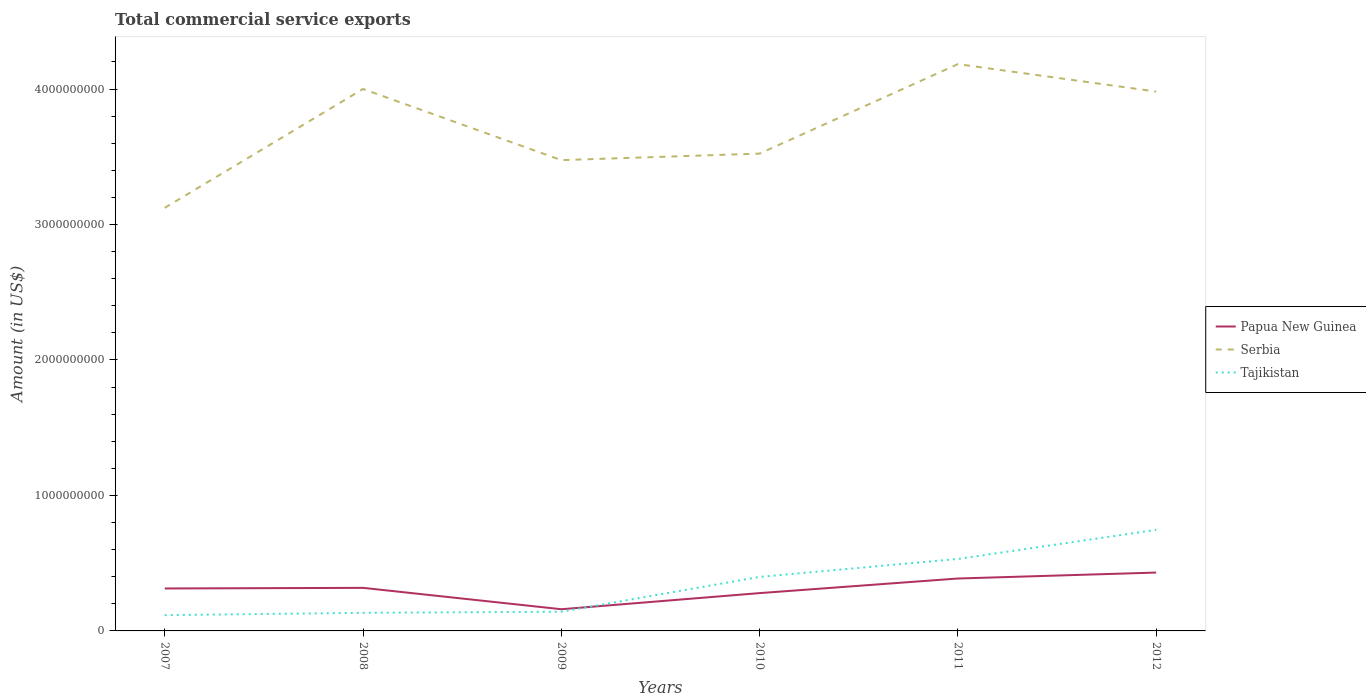How many different coloured lines are there?
Give a very brief answer. 3. Across all years, what is the maximum total commercial service exports in Tajikistan?
Ensure brevity in your answer.  1.16e+08. In which year was the total commercial service exports in Tajikistan maximum?
Provide a succinct answer. 2007. What is the total total commercial service exports in Tajikistan in the graph?
Ensure brevity in your answer.  -6.30e+08. What is the difference between the highest and the second highest total commercial service exports in Serbia?
Make the answer very short. 1.06e+09. Is the total commercial service exports in Papua New Guinea strictly greater than the total commercial service exports in Tajikistan over the years?
Offer a terse response. No. How many years are there in the graph?
Your response must be concise. 6. What is the difference between two consecutive major ticks on the Y-axis?
Provide a succinct answer. 1.00e+09. Does the graph contain grids?
Offer a very short reply. No. Where does the legend appear in the graph?
Provide a succinct answer. Center right. How many legend labels are there?
Your answer should be compact. 3. How are the legend labels stacked?
Offer a terse response. Vertical. What is the title of the graph?
Provide a short and direct response. Total commercial service exports. Does "Thailand" appear as one of the legend labels in the graph?
Offer a very short reply. No. What is the Amount (in US$) in Papua New Guinea in 2007?
Ensure brevity in your answer.  3.13e+08. What is the Amount (in US$) of Serbia in 2007?
Keep it short and to the point. 3.12e+09. What is the Amount (in US$) in Tajikistan in 2007?
Give a very brief answer. 1.16e+08. What is the Amount (in US$) in Papua New Guinea in 2008?
Provide a succinct answer. 3.18e+08. What is the Amount (in US$) of Serbia in 2008?
Provide a succinct answer. 4.00e+09. What is the Amount (in US$) in Tajikistan in 2008?
Provide a succinct answer. 1.34e+08. What is the Amount (in US$) in Papua New Guinea in 2009?
Give a very brief answer. 1.60e+08. What is the Amount (in US$) of Serbia in 2009?
Ensure brevity in your answer.  3.48e+09. What is the Amount (in US$) in Tajikistan in 2009?
Provide a succinct answer. 1.42e+08. What is the Amount (in US$) of Papua New Guinea in 2010?
Provide a short and direct response. 2.79e+08. What is the Amount (in US$) of Serbia in 2010?
Your answer should be very brief. 3.52e+09. What is the Amount (in US$) of Tajikistan in 2010?
Make the answer very short. 3.99e+08. What is the Amount (in US$) in Papua New Guinea in 2011?
Offer a terse response. 3.87e+08. What is the Amount (in US$) in Serbia in 2011?
Give a very brief answer. 4.18e+09. What is the Amount (in US$) in Tajikistan in 2011?
Provide a short and direct response. 5.31e+08. What is the Amount (in US$) of Papua New Guinea in 2012?
Make the answer very short. 4.31e+08. What is the Amount (in US$) of Serbia in 2012?
Offer a very short reply. 3.98e+09. What is the Amount (in US$) in Tajikistan in 2012?
Your answer should be compact. 7.46e+08. Across all years, what is the maximum Amount (in US$) of Papua New Guinea?
Offer a very short reply. 4.31e+08. Across all years, what is the maximum Amount (in US$) of Serbia?
Ensure brevity in your answer.  4.18e+09. Across all years, what is the maximum Amount (in US$) of Tajikistan?
Your response must be concise. 7.46e+08. Across all years, what is the minimum Amount (in US$) in Papua New Guinea?
Make the answer very short. 1.60e+08. Across all years, what is the minimum Amount (in US$) of Serbia?
Your answer should be compact. 3.12e+09. Across all years, what is the minimum Amount (in US$) of Tajikistan?
Make the answer very short. 1.16e+08. What is the total Amount (in US$) in Papua New Guinea in the graph?
Provide a succinct answer. 1.89e+09. What is the total Amount (in US$) of Serbia in the graph?
Your answer should be compact. 2.23e+1. What is the total Amount (in US$) of Tajikistan in the graph?
Offer a very short reply. 2.07e+09. What is the difference between the Amount (in US$) of Papua New Guinea in 2007 and that in 2008?
Make the answer very short. -4.53e+06. What is the difference between the Amount (in US$) in Serbia in 2007 and that in 2008?
Provide a short and direct response. -8.77e+08. What is the difference between the Amount (in US$) in Tajikistan in 2007 and that in 2008?
Your answer should be compact. -1.71e+07. What is the difference between the Amount (in US$) of Papua New Guinea in 2007 and that in 2009?
Your response must be concise. 1.53e+08. What is the difference between the Amount (in US$) of Serbia in 2007 and that in 2009?
Give a very brief answer. -3.52e+08. What is the difference between the Amount (in US$) in Tajikistan in 2007 and that in 2009?
Provide a succinct answer. -2.53e+07. What is the difference between the Amount (in US$) of Papua New Guinea in 2007 and that in 2010?
Ensure brevity in your answer.  3.43e+07. What is the difference between the Amount (in US$) in Serbia in 2007 and that in 2010?
Provide a succinct answer. -4.00e+08. What is the difference between the Amount (in US$) of Tajikistan in 2007 and that in 2010?
Your answer should be very brief. -2.82e+08. What is the difference between the Amount (in US$) of Papua New Guinea in 2007 and that in 2011?
Keep it short and to the point. -7.35e+07. What is the difference between the Amount (in US$) of Serbia in 2007 and that in 2011?
Your answer should be compact. -1.06e+09. What is the difference between the Amount (in US$) in Tajikistan in 2007 and that in 2011?
Make the answer very short. -4.15e+08. What is the difference between the Amount (in US$) in Papua New Guinea in 2007 and that in 2012?
Offer a terse response. -1.17e+08. What is the difference between the Amount (in US$) in Serbia in 2007 and that in 2012?
Provide a succinct answer. -8.58e+08. What is the difference between the Amount (in US$) of Tajikistan in 2007 and that in 2012?
Offer a terse response. -6.30e+08. What is the difference between the Amount (in US$) of Papua New Guinea in 2008 and that in 2009?
Offer a very short reply. 1.58e+08. What is the difference between the Amount (in US$) of Serbia in 2008 and that in 2009?
Keep it short and to the point. 5.25e+08. What is the difference between the Amount (in US$) of Tajikistan in 2008 and that in 2009?
Your response must be concise. -8.19e+06. What is the difference between the Amount (in US$) in Papua New Guinea in 2008 and that in 2010?
Your answer should be compact. 3.88e+07. What is the difference between the Amount (in US$) of Serbia in 2008 and that in 2010?
Offer a very short reply. 4.77e+08. What is the difference between the Amount (in US$) in Tajikistan in 2008 and that in 2010?
Ensure brevity in your answer.  -2.65e+08. What is the difference between the Amount (in US$) of Papua New Guinea in 2008 and that in 2011?
Make the answer very short. -6.90e+07. What is the difference between the Amount (in US$) of Serbia in 2008 and that in 2011?
Your response must be concise. -1.84e+08. What is the difference between the Amount (in US$) in Tajikistan in 2008 and that in 2011?
Offer a terse response. -3.98e+08. What is the difference between the Amount (in US$) in Papua New Guinea in 2008 and that in 2012?
Keep it short and to the point. -1.13e+08. What is the difference between the Amount (in US$) of Serbia in 2008 and that in 2012?
Ensure brevity in your answer.  1.90e+07. What is the difference between the Amount (in US$) of Tajikistan in 2008 and that in 2012?
Offer a terse response. -6.12e+08. What is the difference between the Amount (in US$) in Papua New Guinea in 2009 and that in 2010?
Your answer should be compact. -1.19e+08. What is the difference between the Amount (in US$) of Serbia in 2009 and that in 2010?
Offer a very short reply. -4.81e+07. What is the difference between the Amount (in US$) of Tajikistan in 2009 and that in 2010?
Provide a succinct answer. -2.57e+08. What is the difference between the Amount (in US$) of Papua New Guinea in 2009 and that in 2011?
Offer a terse response. -2.27e+08. What is the difference between the Amount (in US$) of Serbia in 2009 and that in 2011?
Ensure brevity in your answer.  -7.09e+08. What is the difference between the Amount (in US$) of Tajikistan in 2009 and that in 2011?
Offer a terse response. -3.90e+08. What is the difference between the Amount (in US$) in Papua New Guinea in 2009 and that in 2012?
Offer a very short reply. -2.71e+08. What is the difference between the Amount (in US$) of Serbia in 2009 and that in 2012?
Your response must be concise. -5.06e+08. What is the difference between the Amount (in US$) of Tajikistan in 2009 and that in 2012?
Your answer should be very brief. -6.04e+08. What is the difference between the Amount (in US$) of Papua New Guinea in 2010 and that in 2011?
Provide a short and direct response. -1.08e+08. What is the difference between the Amount (in US$) of Serbia in 2010 and that in 2011?
Offer a very short reply. -6.61e+08. What is the difference between the Amount (in US$) in Tajikistan in 2010 and that in 2011?
Provide a short and direct response. -1.33e+08. What is the difference between the Amount (in US$) of Papua New Guinea in 2010 and that in 2012?
Your answer should be very brief. -1.52e+08. What is the difference between the Amount (in US$) in Serbia in 2010 and that in 2012?
Your response must be concise. -4.58e+08. What is the difference between the Amount (in US$) of Tajikistan in 2010 and that in 2012?
Your answer should be very brief. -3.47e+08. What is the difference between the Amount (in US$) of Papua New Guinea in 2011 and that in 2012?
Provide a succinct answer. -4.38e+07. What is the difference between the Amount (in US$) of Serbia in 2011 and that in 2012?
Offer a terse response. 2.03e+08. What is the difference between the Amount (in US$) of Tajikistan in 2011 and that in 2012?
Offer a very short reply. -2.15e+08. What is the difference between the Amount (in US$) in Papua New Guinea in 2007 and the Amount (in US$) in Serbia in 2008?
Offer a terse response. -3.69e+09. What is the difference between the Amount (in US$) of Papua New Guinea in 2007 and the Amount (in US$) of Tajikistan in 2008?
Make the answer very short. 1.80e+08. What is the difference between the Amount (in US$) in Serbia in 2007 and the Amount (in US$) in Tajikistan in 2008?
Make the answer very short. 2.99e+09. What is the difference between the Amount (in US$) in Papua New Guinea in 2007 and the Amount (in US$) in Serbia in 2009?
Provide a succinct answer. -3.16e+09. What is the difference between the Amount (in US$) of Papua New Guinea in 2007 and the Amount (in US$) of Tajikistan in 2009?
Provide a succinct answer. 1.72e+08. What is the difference between the Amount (in US$) in Serbia in 2007 and the Amount (in US$) in Tajikistan in 2009?
Provide a short and direct response. 2.98e+09. What is the difference between the Amount (in US$) in Papua New Guinea in 2007 and the Amount (in US$) in Serbia in 2010?
Make the answer very short. -3.21e+09. What is the difference between the Amount (in US$) of Papua New Guinea in 2007 and the Amount (in US$) of Tajikistan in 2010?
Offer a very short reply. -8.54e+07. What is the difference between the Amount (in US$) of Serbia in 2007 and the Amount (in US$) of Tajikistan in 2010?
Ensure brevity in your answer.  2.72e+09. What is the difference between the Amount (in US$) of Papua New Guinea in 2007 and the Amount (in US$) of Serbia in 2011?
Your answer should be very brief. -3.87e+09. What is the difference between the Amount (in US$) in Papua New Guinea in 2007 and the Amount (in US$) in Tajikistan in 2011?
Provide a succinct answer. -2.18e+08. What is the difference between the Amount (in US$) in Serbia in 2007 and the Amount (in US$) in Tajikistan in 2011?
Your response must be concise. 2.59e+09. What is the difference between the Amount (in US$) of Papua New Guinea in 2007 and the Amount (in US$) of Serbia in 2012?
Provide a succinct answer. -3.67e+09. What is the difference between the Amount (in US$) of Papua New Guinea in 2007 and the Amount (in US$) of Tajikistan in 2012?
Provide a succinct answer. -4.33e+08. What is the difference between the Amount (in US$) of Serbia in 2007 and the Amount (in US$) of Tajikistan in 2012?
Ensure brevity in your answer.  2.38e+09. What is the difference between the Amount (in US$) in Papua New Guinea in 2008 and the Amount (in US$) in Serbia in 2009?
Make the answer very short. -3.16e+09. What is the difference between the Amount (in US$) of Papua New Guinea in 2008 and the Amount (in US$) of Tajikistan in 2009?
Your response must be concise. 1.76e+08. What is the difference between the Amount (in US$) of Serbia in 2008 and the Amount (in US$) of Tajikistan in 2009?
Your response must be concise. 3.86e+09. What is the difference between the Amount (in US$) of Papua New Guinea in 2008 and the Amount (in US$) of Serbia in 2010?
Offer a very short reply. -3.21e+09. What is the difference between the Amount (in US$) of Papua New Guinea in 2008 and the Amount (in US$) of Tajikistan in 2010?
Your response must be concise. -8.09e+07. What is the difference between the Amount (in US$) in Serbia in 2008 and the Amount (in US$) in Tajikistan in 2010?
Give a very brief answer. 3.60e+09. What is the difference between the Amount (in US$) of Papua New Guinea in 2008 and the Amount (in US$) of Serbia in 2011?
Your answer should be very brief. -3.87e+09. What is the difference between the Amount (in US$) of Papua New Guinea in 2008 and the Amount (in US$) of Tajikistan in 2011?
Your answer should be compact. -2.13e+08. What is the difference between the Amount (in US$) of Serbia in 2008 and the Amount (in US$) of Tajikistan in 2011?
Make the answer very short. 3.47e+09. What is the difference between the Amount (in US$) of Papua New Guinea in 2008 and the Amount (in US$) of Serbia in 2012?
Keep it short and to the point. -3.66e+09. What is the difference between the Amount (in US$) in Papua New Guinea in 2008 and the Amount (in US$) in Tajikistan in 2012?
Keep it short and to the point. -4.28e+08. What is the difference between the Amount (in US$) of Serbia in 2008 and the Amount (in US$) of Tajikistan in 2012?
Your answer should be compact. 3.25e+09. What is the difference between the Amount (in US$) in Papua New Guinea in 2009 and the Amount (in US$) in Serbia in 2010?
Provide a short and direct response. -3.36e+09. What is the difference between the Amount (in US$) of Papua New Guinea in 2009 and the Amount (in US$) of Tajikistan in 2010?
Ensure brevity in your answer.  -2.39e+08. What is the difference between the Amount (in US$) of Serbia in 2009 and the Amount (in US$) of Tajikistan in 2010?
Your answer should be compact. 3.08e+09. What is the difference between the Amount (in US$) of Papua New Guinea in 2009 and the Amount (in US$) of Serbia in 2011?
Your response must be concise. -4.02e+09. What is the difference between the Amount (in US$) of Papua New Guinea in 2009 and the Amount (in US$) of Tajikistan in 2011?
Provide a succinct answer. -3.71e+08. What is the difference between the Amount (in US$) of Serbia in 2009 and the Amount (in US$) of Tajikistan in 2011?
Give a very brief answer. 2.94e+09. What is the difference between the Amount (in US$) in Papua New Guinea in 2009 and the Amount (in US$) in Serbia in 2012?
Make the answer very short. -3.82e+09. What is the difference between the Amount (in US$) of Papua New Guinea in 2009 and the Amount (in US$) of Tajikistan in 2012?
Your answer should be very brief. -5.86e+08. What is the difference between the Amount (in US$) in Serbia in 2009 and the Amount (in US$) in Tajikistan in 2012?
Offer a terse response. 2.73e+09. What is the difference between the Amount (in US$) in Papua New Guinea in 2010 and the Amount (in US$) in Serbia in 2011?
Offer a terse response. -3.90e+09. What is the difference between the Amount (in US$) of Papua New Guinea in 2010 and the Amount (in US$) of Tajikistan in 2011?
Provide a succinct answer. -2.52e+08. What is the difference between the Amount (in US$) of Serbia in 2010 and the Amount (in US$) of Tajikistan in 2011?
Provide a succinct answer. 2.99e+09. What is the difference between the Amount (in US$) in Papua New Guinea in 2010 and the Amount (in US$) in Serbia in 2012?
Ensure brevity in your answer.  -3.70e+09. What is the difference between the Amount (in US$) in Papua New Guinea in 2010 and the Amount (in US$) in Tajikistan in 2012?
Provide a short and direct response. -4.67e+08. What is the difference between the Amount (in US$) of Serbia in 2010 and the Amount (in US$) of Tajikistan in 2012?
Your response must be concise. 2.78e+09. What is the difference between the Amount (in US$) of Papua New Guinea in 2011 and the Amount (in US$) of Serbia in 2012?
Provide a short and direct response. -3.59e+09. What is the difference between the Amount (in US$) of Papua New Guinea in 2011 and the Amount (in US$) of Tajikistan in 2012?
Your answer should be compact. -3.59e+08. What is the difference between the Amount (in US$) in Serbia in 2011 and the Amount (in US$) in Tajikistan in 2012?
Your response must be concise. 3.44e+09. What is the average Amount (in US$) in Papua New Guinea per year?
Make the answer very short. 3.15e+08. What is the average Amount (in US$) in Serbia per year?
Offer a terse response. 3.71e+09. What is the average Amount (in US$) of Tajikistan per year?
Provide a short and direct response. 3.45e+08. In the year 2007, what is the difference between the Amount (in US$) in Papua New Guinea and Amount (in US$) in Serbia?
Your answer should be very brief. -2.81e+09. In the year 2007, what is the difference between the Amount (in US$) of Papua New Guinea and Amount (in US$) of Tajikistan?
Keep it short and to the point. 1.97e+08. In the year 2007, what is the difference between the Amount (in US$) in Serbia and Amount (in US$) in Tajikistan?
Ensure brevity in your answer.  3.01e+09. In the year 2008, what is the difference between the Amount (in US$) of Papua New Guinea and Amount (in US$) of Serbia?
Your response must be concise. -3.68e+09. In the year 2008, what is the difference between the Amount (in US$) in Papua New Guinea and Amount (in US$) in Tajikistan?
Offer a very short reply. 1.84e+08. In the year 2008, what is the difference between the Amount (in US$) in Serbia and Amount (in US$) in Tajikistan?
Provide a succinct answer. 3.87e+09. In the year 2009, what is the difference between the Amount (in US$) in Papua New Guinea and Amount (in US$) in Serbia?
Your response must be concise. -3.32e+09. In the year 2009, what is the difference between the Amount (in US$) of Papua New Guinea and Amount (in US$) of Tajikistan?
Your answer should be very brief. 1.84e+07. In the year 2009, what is the difference between the Amount (in US$) in Serbia and Amount (in US$) in Tajikistan?
Your answer should be compact. 3.33e+09. In the year 2010, what is the difference between the Amount (in US$) of Papua New Guinea and Amount (in US$) of Serbia?
Provide a succinct answer. -3.24e+09. In the year 2010, what is the difference between the Amount (in US$) of Papua New Guinea and Amount (in US$) of Tajikistan?
Your response must be concise. -1.20e+08. In the year 2010, what is the difference between the Amount (in US$) in Serbia and Amount (in US$) in Tajikistan?
Provide a short and direct response. 3.12e+09. In the year 2011, what is the difference between the Amount (in US$) of Papua New Guinea and Amount (in US$) of Serbia?
Your answer should be compact. -3.80e+09. In the year 2011, what is the difference between the Amount (in US$) of Papua New Guinea and Amount (in US$) of Tajikistan?
Provide a short and direct response. -1.44e+08. In the year 2011, what is the difference between the Amount (in US$) of Serbia and Amount (in US$) of Tajikistan?
Your answer should be compact. 3.65e+09. In the year 2012, what is the difference between the Amount (in US$) in Papua New Guinea and Amount (in US$) in Serbia?
Keep it short and to the point. -3.55e+09. In the year 2012, what is the difference between the Amount (in US$) in Papua New Guinea and Amount (in US$) in Tajikistan?
Your answer should be very brief. -3.15e+08. In the year 2012, what is the difference between the Amount (in US$) in Serbia and Amount (in US$) in Tajikistan?
Give a very brief answer. 3.24e+09. What is the ratio of the Amount (in US$) in Papua New Guinea in 2007 to that in 2008?
Offer a terse response. 0.99. What is the ratio of the Amount (in US$) in Serbia in 2007 to that in 2008?
Your response must be concise. 0.78. What is the ratio of the Amount (in US$) in Tajikistan in 2007 to that in 2008?
Provide a succinct answer. 0.87. What is the ratio of the Amount (in US$) of Papua New Guinea in 2007 to that in 2009?
Your response must be concise. 1.96. What is the ratio of the Amount (in US$) in Serbia in 2007 to that in 2009?
Offer a very short reply. 0.9. What is the ratio of the Amount (in US$) of Tajikistan in 2007 to that in 2009?
Your answer should be very brief. 0.82. What is the ratio of the Amount (in US$) in Papua New Guinea in 2007 to that in 2010?
Ensure brevity in your answer.  1.12. What is the ratio of the Amount (in US$) in Serbia in 2007 to that in 2010?
Your response must be concise. 0.89. What is the ratio of the Amount (in US$) of Tajikistan in 2007 to that in 2010?
Provide a succinct answer. 0.29. What is the ratio of the Amount (in US$) of Papua New Guinea in 2007 to that in 2011?
Offer a very short reply. 0.81. What is the ratio of the Amount (in US$) of Serbia in 2007 to that in 2011?
Your answer should be compact. 0.75. What is the ratio of the Amount (in US$) of Tajikistan in 2007 to that in 2011?
Keep it short and to the point. 0.22. What is the ratio of the Amount (in US$) of Papua New Guinea in 2007 to that in 2012?
Your response must be concise. 0.73. What is the ratio of the Amount (in US$) in Serbia in 2007 to that in 2012?
Keep it short and to the point. 0.78. What is the ratio of the Amount (in US$) of Tajikistan in 2007 to that in 2012?
Your answer should be compact. 0.16. What is the ratio of the Amount (in US$) in Papua New Guinea in 2008 to that in 2009?
Keep it short and to the point. 1.99. What is the ratio of the Amount (in US$) of Serbia in 2008 to that in 2009?
Ensure brevity in your answer.  1.15. What is the ratio of the Amount (in US$) in Tajikistan in 2008 to that in 2009?
Give a very brief answer. 0.94. What is the ratio of the Amount (in US$) of Papua New Guinea in 2008 to that in 2010?
Your answer should be very brief. 1.14. What is the ratio of the Amount (in US$) in Serbia in 2008 to that in 2010?
Make the answer very short. 1.14. What is the ratio of the Amount (in US$) in Tajikistan in 2008 to that in 2010?
Offer a terse response. 0.33. What is the ratio of the Amount (in US$) in Papua New Guinea in 2008 to that in 2011?
Your answer should be compact. 0.82. What is the ratio of the Amount (in US$) in Serbia in 2008 to that in 2011?
Your response must be concise. 0.96. What is the ratio of the Amount (in US$) of Tajikistan in 2008 to that in 2011?
Offer a very short reply. 0.25. What is the ratio of the Amount (in US$) of Papua New Guinea in 2008 to that in 2012?
Offer a terse response. 0.74. What is the ratio of the Amount (in US$) in Tajikistan in 2008 to that in 2012?
Make the answer very short. 0.18. What is the ratio of the Amount (in US$) in Papua New Guinea in 2009 to that in 2010?
Keep it short and to the point. 0.57. What is the ratio of the Amount (in US$) in Serbia in 2009 to that in 2010?
Make the answer very short. 0.99. What is the ratio of the Amount (in US$) of Tajikistan in 2009 to that in 2010?
Your answer should be compact. 0.36. What is the ratio of the Amount (in US$) in Papua New Guinea in 2009 to that in 2011?
Give a very brief answer. 0.41. What is the ratio of the Amount (in US$) of Serbia in 2009 to that in 2011?
Offer a very short reply. 0.83. What is the ratio of the Amount (in US$) in Tajikistan in 2009 to that in 2011?
Offer a very short reply. 0.27. What is the ratio of the Amount (in US$) of Papua New Guinea in 2009 to that in 2012?
Provide a succinct answer. 0.37. What is the ratio of the Amount (in US$) of Serbia in 2009 to that in 2012?
Your answer should be very brief. 0.87. What is the ratio of the Amount (in US$) in Tajikistan in 2009 to that in 2012?
Offer a terse response. 0.19. What is the ratio of the Amount (in US$) in Papua New Guinea in 2010 to that in 2011?
Keep it short and to the point. 0.72. What is the ratio of the Amount (in US$) in Serbia in 2010 to that in 2011?
Your response must be concise. 0.84. What is the ratio of the Amount (in US$) of Tajikistan in 2010 to that in 2011?
Provide a short and direct response. 0.75. What is the ratio of the Amount (in US$) of Papua New Guinea in 2010 to that in 2012?
Provide a succinct answer. 0.65. What is the ratio of the Amount (in US$) of Serbia in 2010 to that in 2012?
Provide a succinct answer. 0.89. What is the ratio of the Amount (in US$) in Tajikistan in 2010 to that in 2012?
Offer a terse response. 0.53. What is the ratio of the Amount (in US$) in Papua New Guinea in 2011 to that in 2012?
Provide a succinct answer. 0.9. What is the ratio of the Amount (in US$) in Serbia in 2011 to that in 2012?
Give a very brief answer. 1.05. What is the ratio of the Amount (in US$) of Tajikistan in 2011 to that in 2012?
Provide a short and direct response. 0.71. What is the difference between the highest and the second highest Amount (in US$) in Papua New Guinea?
Your answer should be compact. 4.38e+07. What is the difference between the highest and the second highest Amount (in US$) in Serbia?
Your answer should be very brief. 1.84e+08. What is the difference between the highest and the second highest Amount (in US$) in Tajikistan?
Provide a succinct answer. 2.15e+08. What is the difference between the highest and the lowest Amount (in US$) of Papua New Guinea?
Your response must be concise. 2.71e+08. What is the difference between the highest and the lowest Amount (in US$) of Serbia?
Provide a short and direct response. 1.06e+09. What is the difference between the highest and the lowest Amount (in US$) of Tajikistan?
Ensure brevity in your answer.  6.30e+08. 